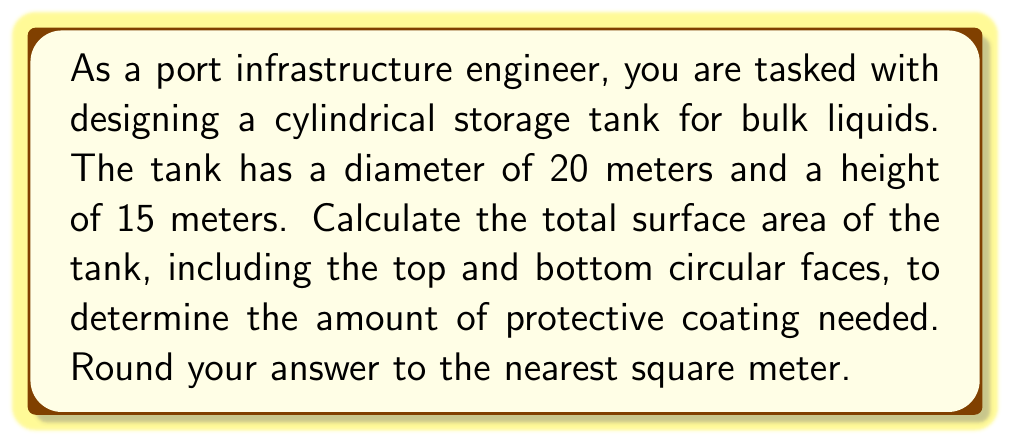Give your solution to this math problem. To calculate the total surface area of a cylindrical tank, we need to consider three components:
1. The lateral surface area (curved side)
2. The top circular face
3. The bottom circular face

Let's break it down step-by-step:

1. Lateral surface area:
   The formula for the lateral surface area of a cylinder is $A_l = 2\pi rh$, where $r$ is the radius and $h$ is the height.
   
   Radius $r = \frac{diameter}{2} = \frac{20}{2} = 10$ meters
   Height $h = 15$ meters
   
   $$A_l = 2\pi(10)(15) = 300\pi \approx 942.48 \text{ m}^2$$

2. Area of top and bottom circular faces:
   The formula for the area of a circle is $A_c = \pi r^2$
   
   $$A_c = \pi(10)^2 = 100\pi \approx 314.16 \text{ m}^2$$
   
   Since there are two circular faces (top and bottom), we multiply this by 2:
   $$A_{circles} = 2(100\pi) = 200\pi \approx 628.32 \text{ m}^2$$

3. Total surface area:
   Sum the lateral surface area and the areas of the two circular faces:
   
   $$A_{total} = A_l + A_{circles} = 300\pi + 200\pi = 500\pi \approx 1570.80 \text{ m}^2$$

Rounding to the nearest square meter:

$$A_{total} \approx 1571 \text{ m}^2$$

[asy]
import geometry;

// Define tank dimensions
real r = 50;
real h = 75;

// Draw cylinder
path3 base = circle((0,0,0), r);
path3 top = circle((0,0,h), r);
draw(surface(base -- top), lightgray);
draw(base, linewidth(1));
draw(top, linewidth(1));

// Draw dashed lines
draw((r,0,0) -- (r,0,h), dashed);
draw((-r,0,0) -- (-r,0,h), dashed);

// Label dimensions
label("20 m", (r/2,-5,0), S);
label("15 m", (r+5,0,h/2), E);

// Set viewpoint
currentprojection = perspective(6*r,4*r,3*r);
[/asy]
Answer: The total surface area of the cylindrical storage tank is approximately 1,571 square meters. 